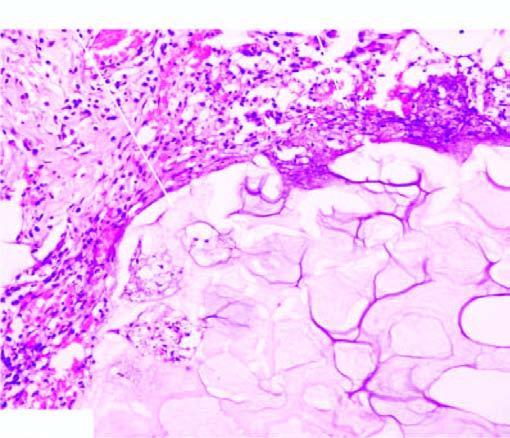does the necrosed area on right side of the field show a few mixed inflammatory cells?
Answer the question using a single word or phrase. No 